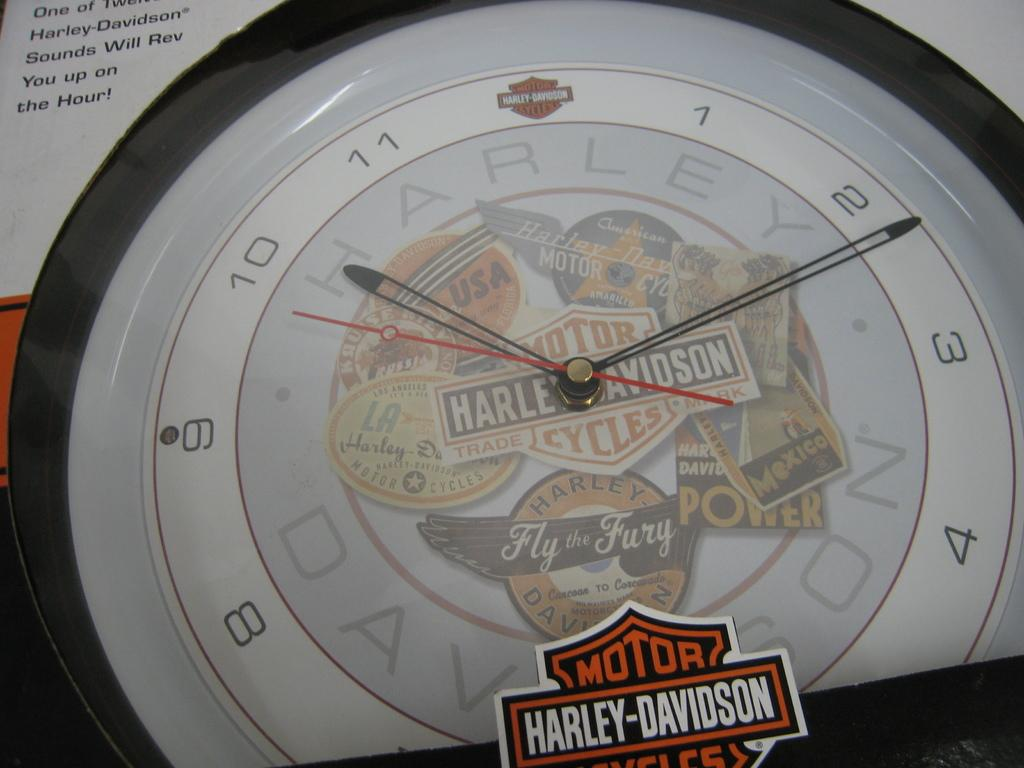<image>
Share a concise interpretation of the image provided. A clock made by Harley Davidson motorcycles  that says fly the fury. 